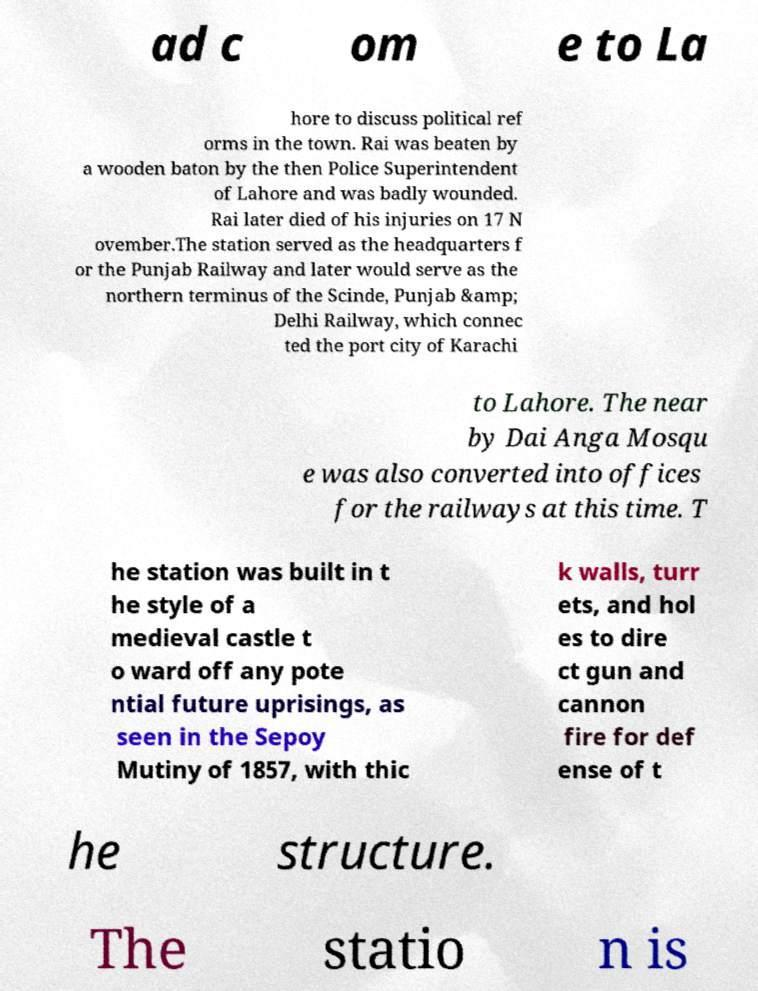Can you read and provide the text displayed in the image?This photo seems to have some interesting text. Can you extract and type it out for me? ad c om e to La hore to discuss political ref orms in the town. Rai was beaten by a wooden baton by the then Police Superintendent of Lahore and was badly wounded. Rai later died of his injuries on 17 N ovember.The station served as the headquarters f or the Punjab Railway and later would serve as the northern terminus of the Scinde, Punjab &amp; Delhi Railway, which connec ted the port city of Karachi to Lahore. The near by Dai Anga Mosqu e was also converted into offices for the railways at this time. T he station was built in t he style of a medieval castle t o ward off any pote ntial future uprisings, as seen in the Sepoy Mutiny of 1857, with thic k walls, turr ets, and hol es to dire ct gun and cannon fire for def ense of t he structure. The statio n is 